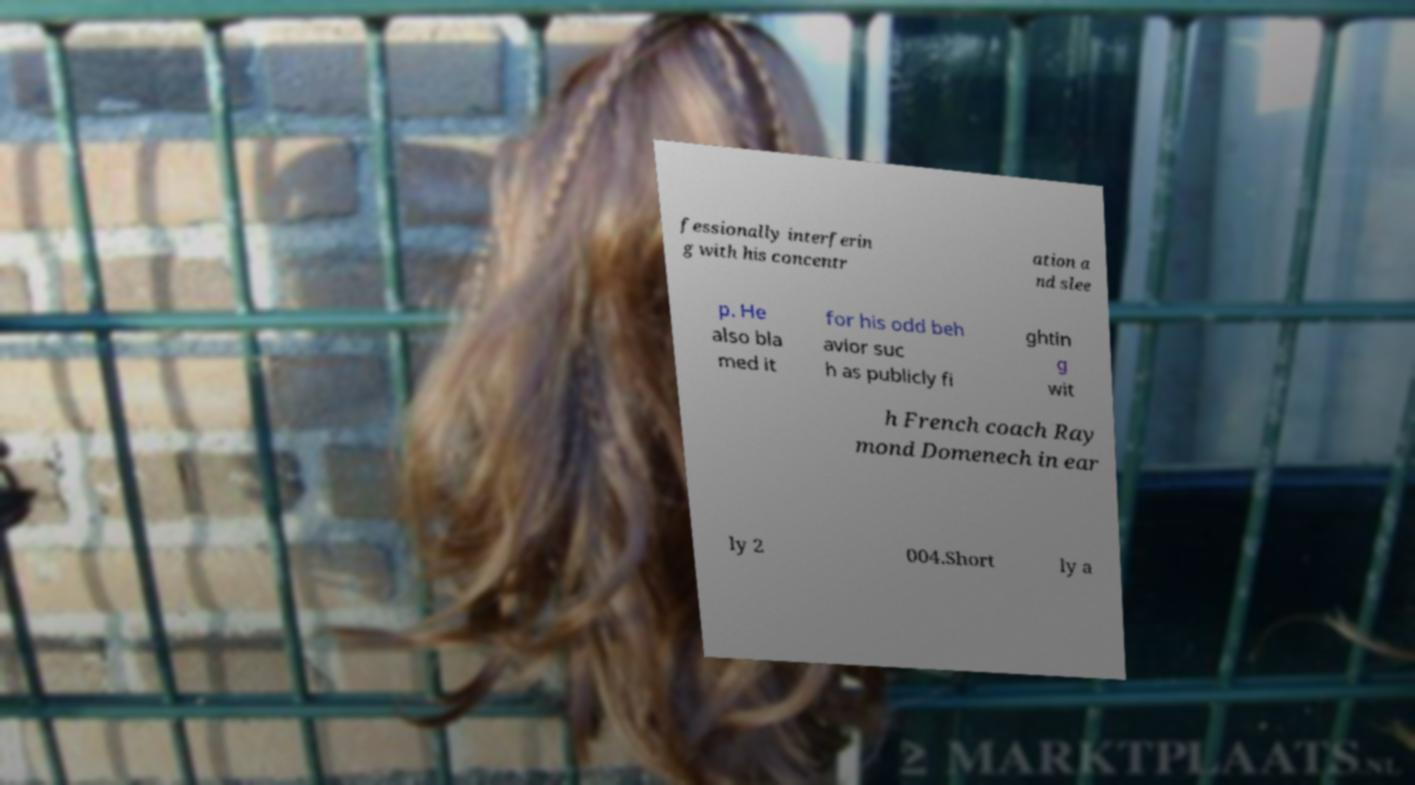Please identify and transcribe the text found in this image. fessionally interferin g with his concentr ation a nd slee p. He also bla med it for his odd beh avior suc h as publicly fi ghtin g wit h French coach Ray mond Domenech in ear ly 2 004.Short ly a 